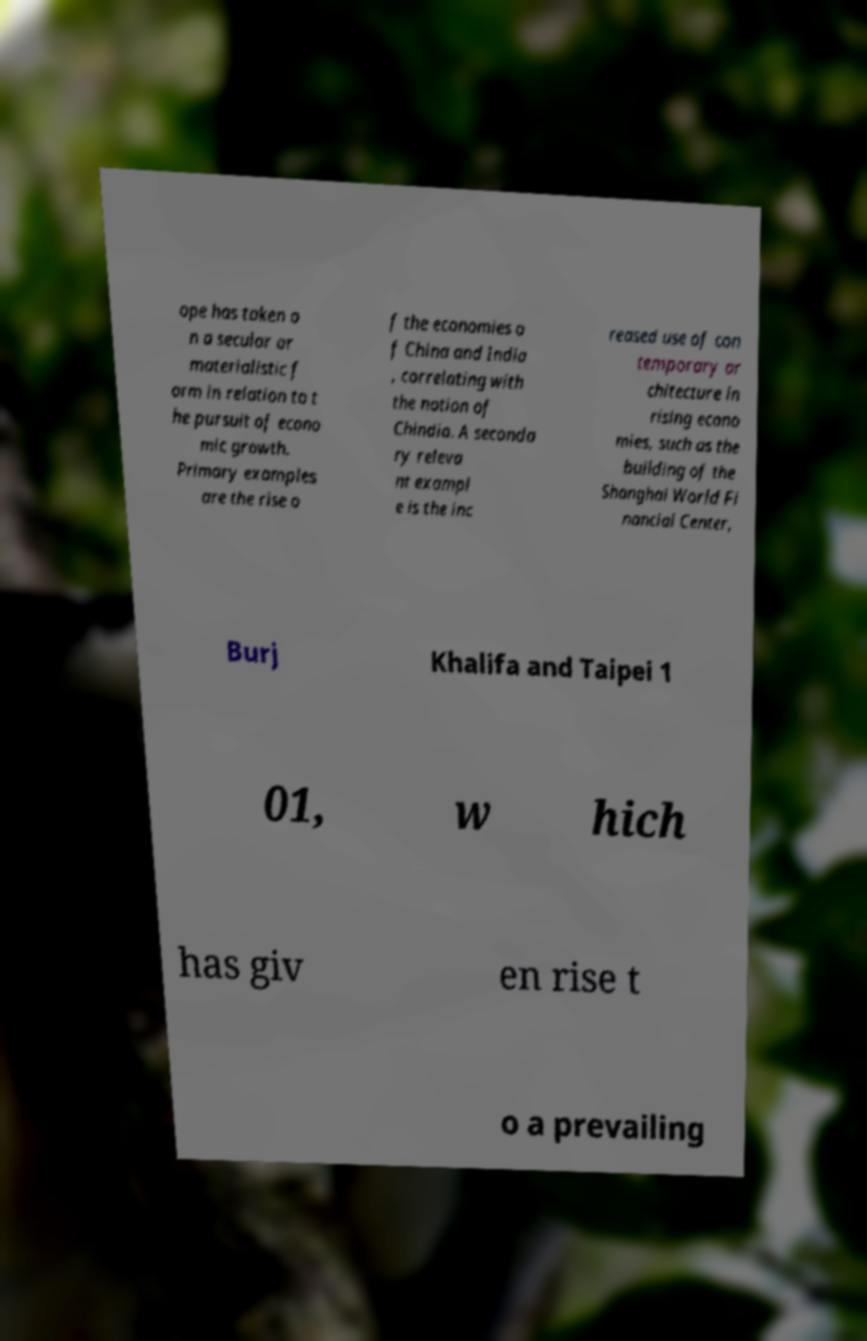Can you accurately transcribe the text from the provided image for me? ope has taken o n a secular or materialistic f orm in relation to t he pursuit of econo mic growth. Primary examples are the rise o f the economies o f China and India , correlating with the notion of Chindia. A seconda ry releva nt exampl e is the inc reased use of con temporary ar chitecture in rising econo mies, such as the building of the Shanghai World Fi nancial Center, Burj Khalifa and Taipei 1 01, w hich has giv en rise t o a prevailing 